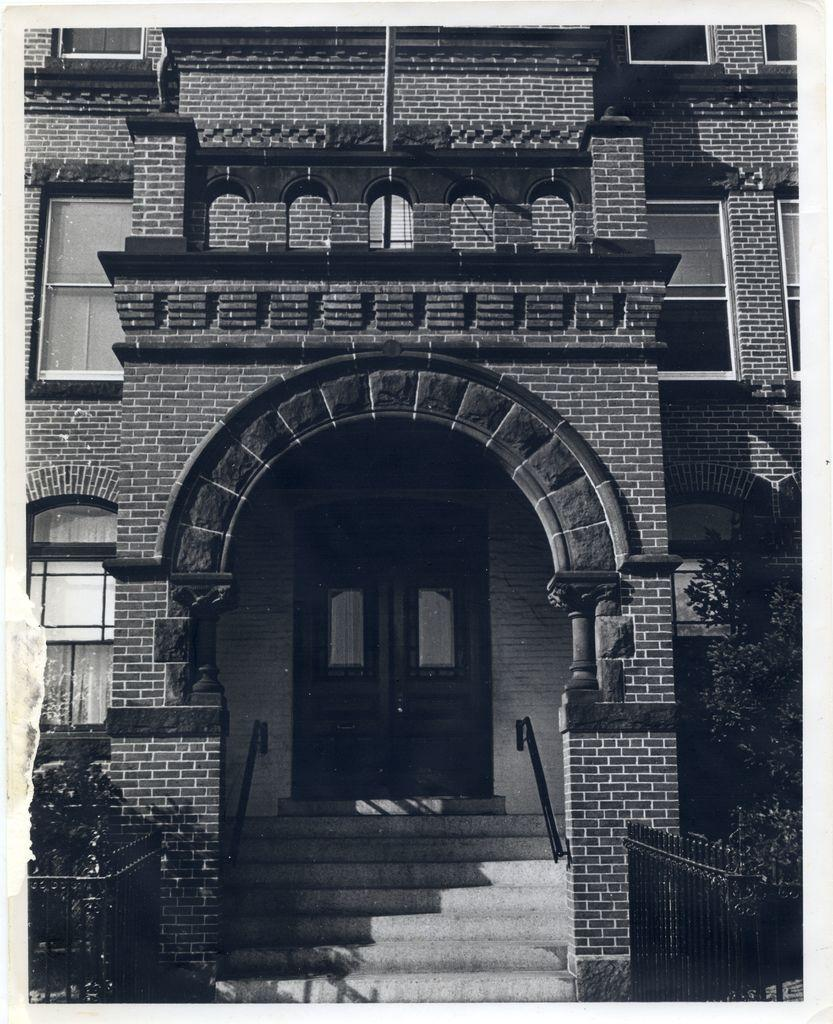What type of structure is present in the image? There is a building in the image. Are there any architectural features visible in the image? Yes, there are steps in the image. What is the purpose of the fence in the image? The fence serves as a boundary or barrier in the image. What type of vegetation can be seen in the image? There are plants in the image. How many doors are visible in the image? There are doors in the image. How many windows are visible in the image? There are windows in the image. What is the color scheme of the image? The image is black and white in color. What type of insurance policy is being discussed in the image? There is no discussion of insurance policies in the image; it is a black and white image of a building with various architectural features. 